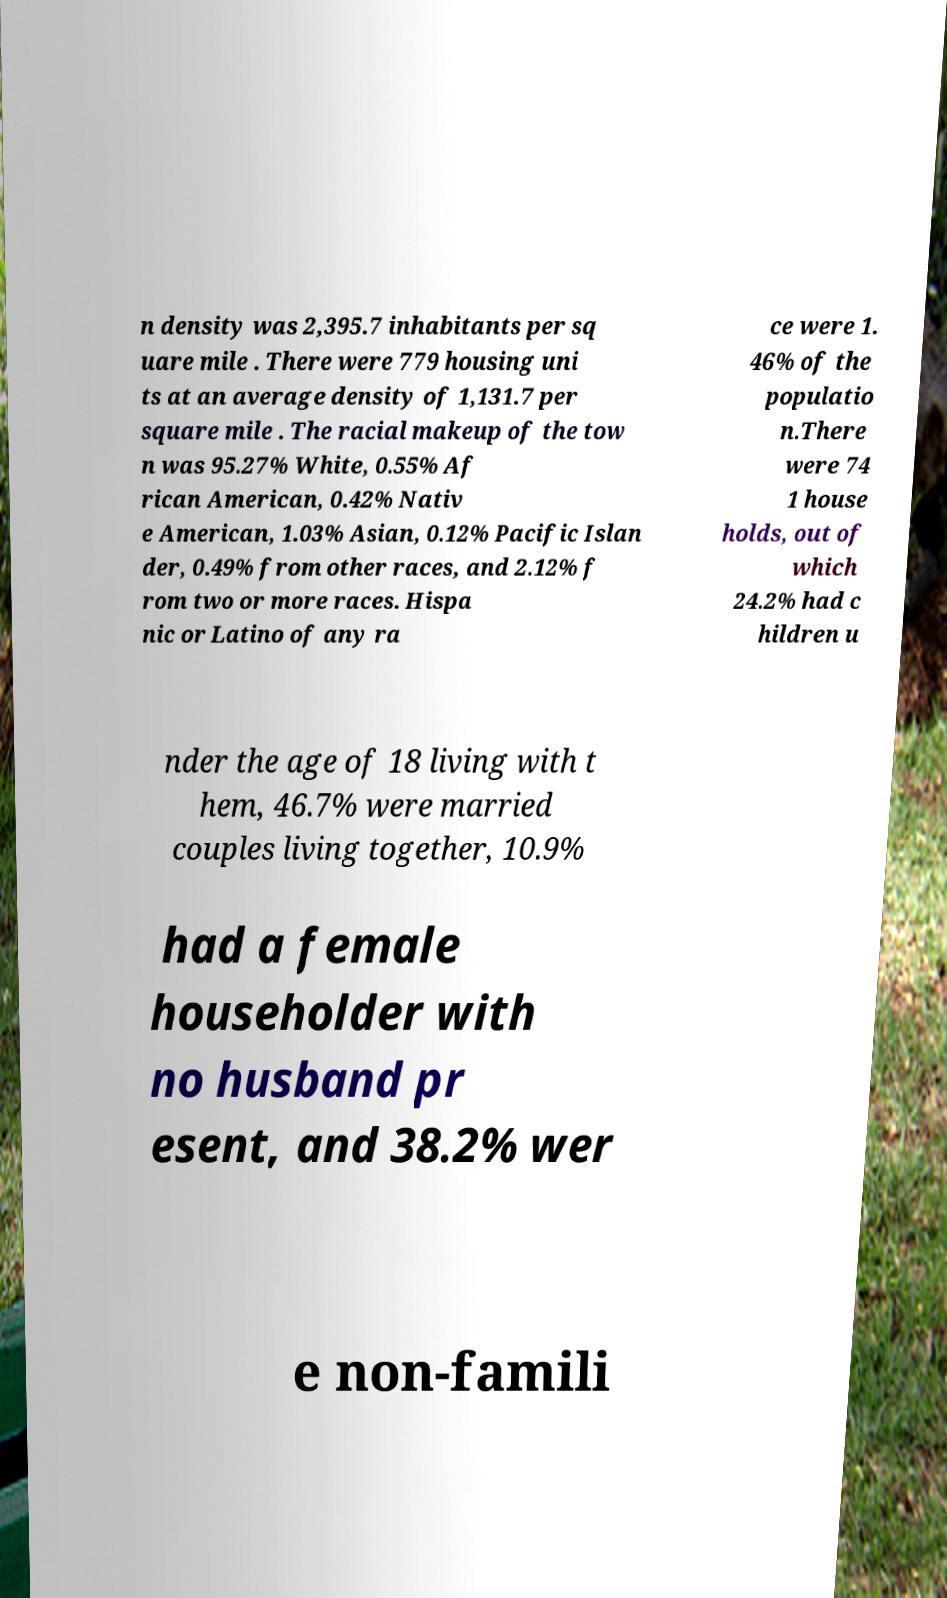Could you extract and type out the text from this image? n density was 2,395.7 inhabitants per sq uare mile . There were 779 housing uni ts at an average density of 1,131.7 per square mile . The racial makeup of the tow n was 95.27% White, 0.55% Af rican American, 0.42% Nativ e American, 1.03% Asian, 0.12% Pacific Islan der, 0.49% from other races, and 2.12% f rom two or more races. Hispa nic or Latino of any ra ce were 1. 46% of the populatio n.There were 74 1 house holds, out of which 24.2% had c hildren u nder the age of 18 living with t hem, 46.7% were married couples living together, 10.9% had a female householder with no husband pr esent, and 38.2% wer e non-famili 